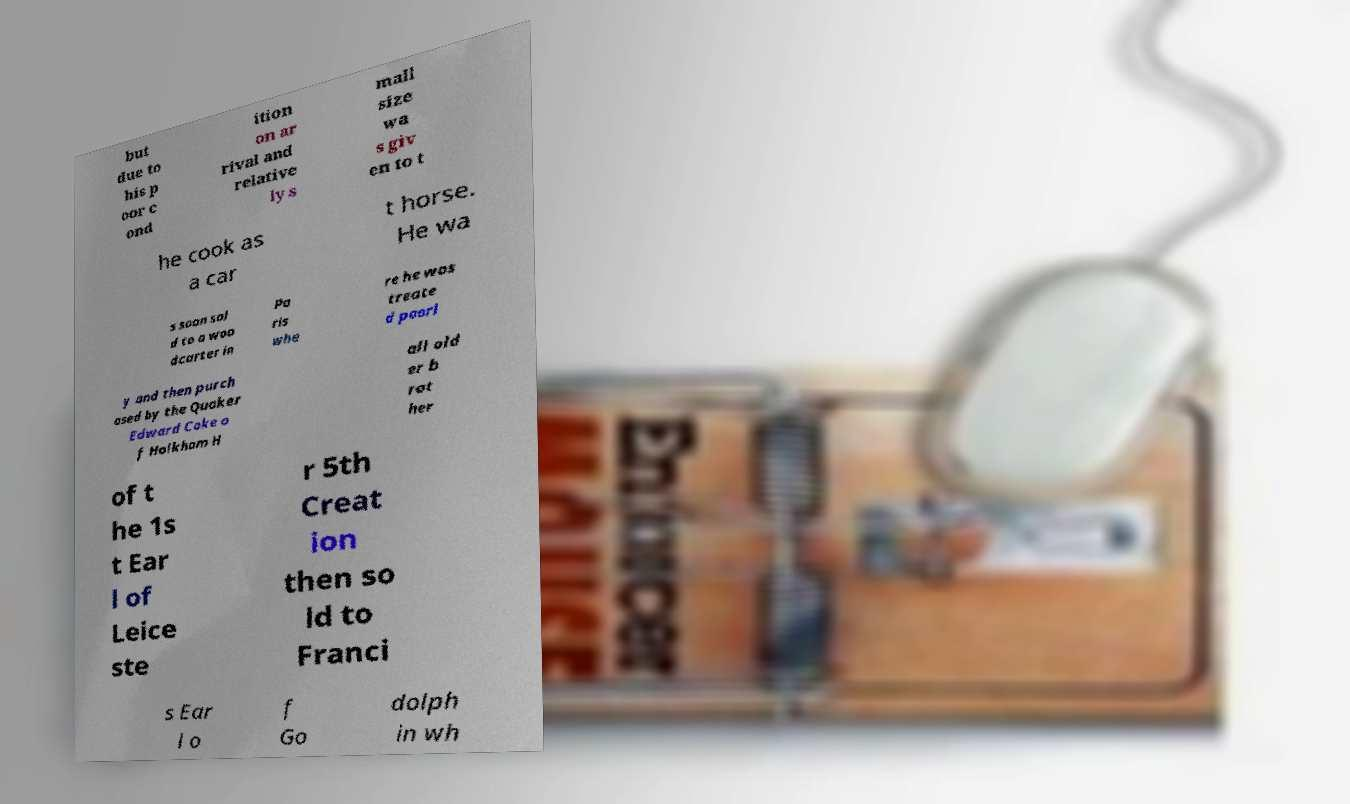Please identify and transcribe the text found in this image. but due to his p oor c ond ition on ar rival and relative ly s mall size wa s giv en to t he cook as a car t horse. He wa s soon sol d to a woo dcarter in Pa ris whe re he was treate d poorl y and then purch ased by the Quaker Edward Coke o f Holkham H all old er b rot her of t he 1s t Ear l of Leice ste r 5th Creat ion then so ld to Franci s Ear l o f Go dolph in wh 